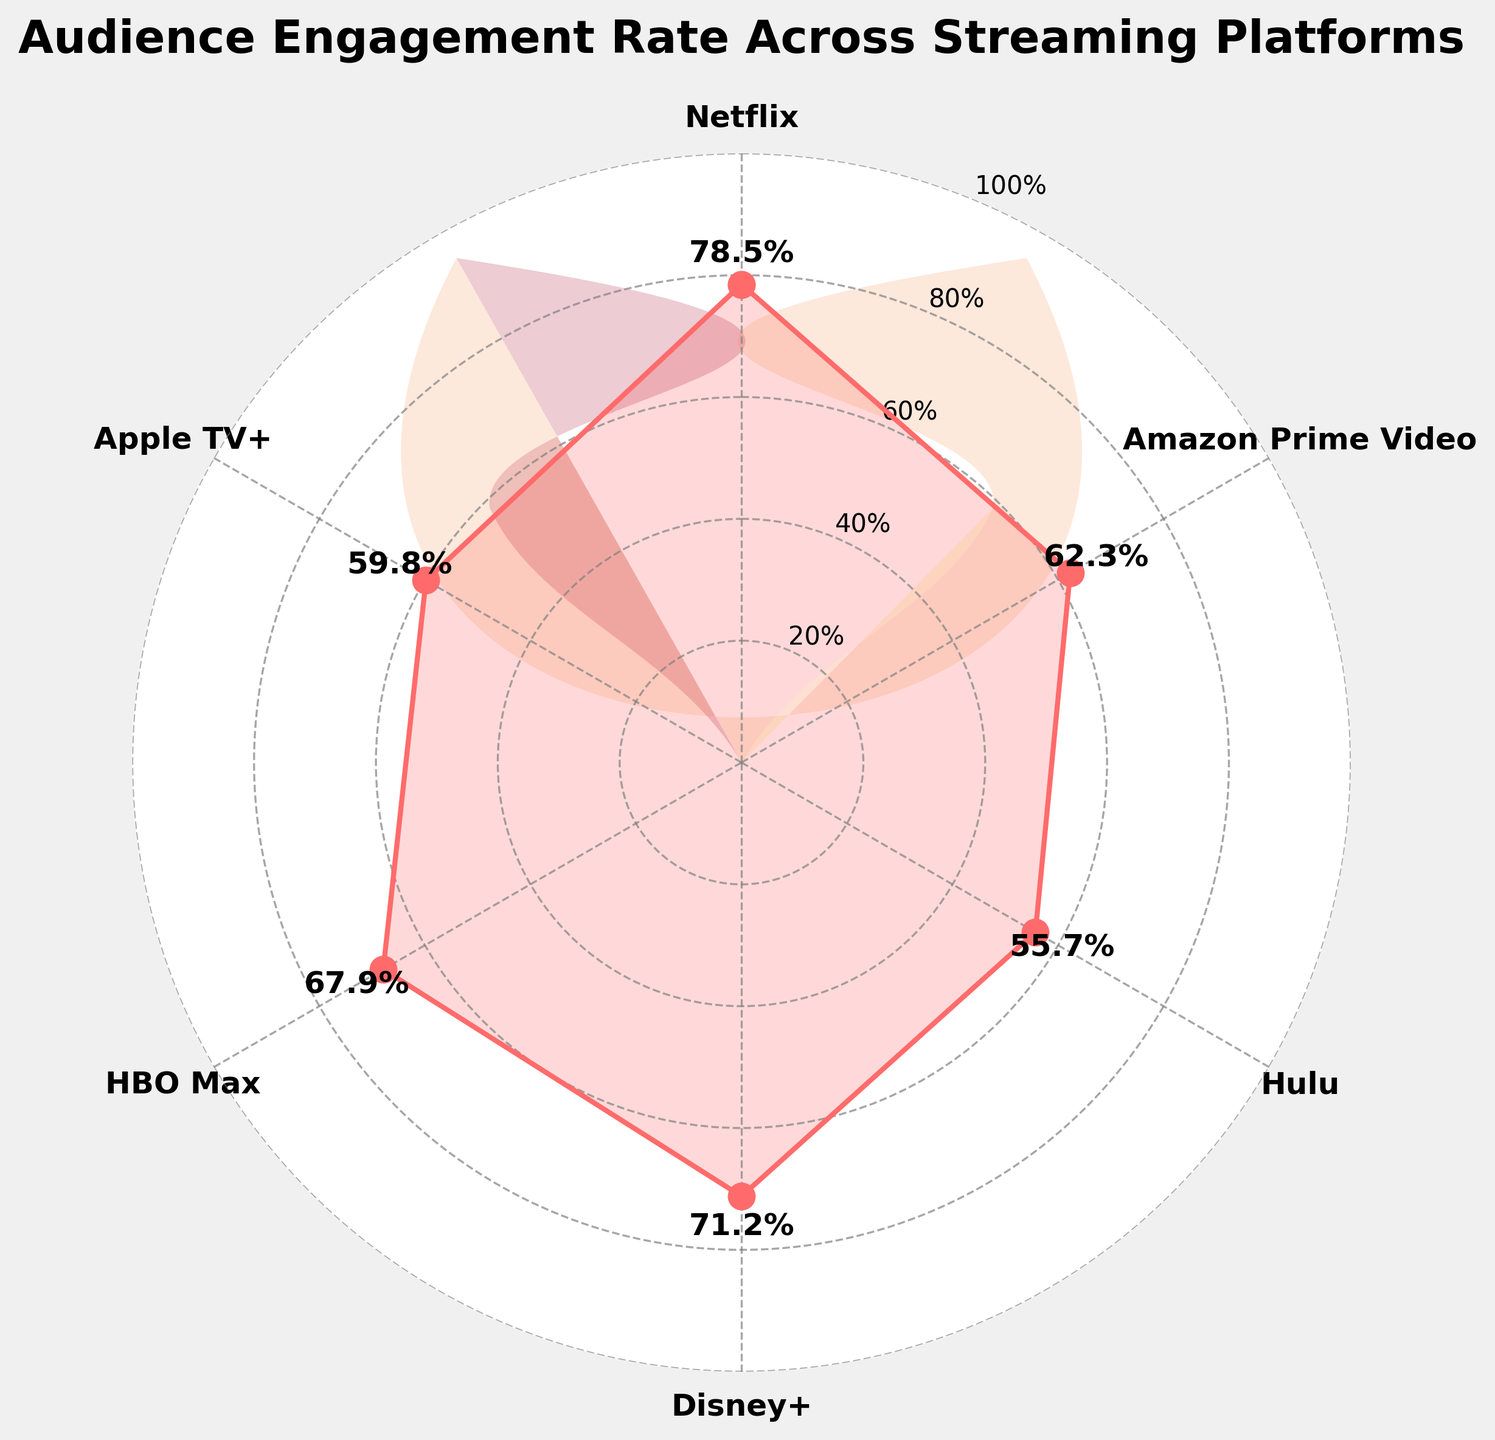What is the title of the figure? The title of the figure is typically displayed at the top of the plot. In this case, it reads "Audience Engagement Rate Across Streaming Platforms".
Answer: "Audience Engagement Rate Across Streaming Platforms" How many streaming platforms are represented in the figure? The figure shows data points for various streaming platforms. Counting the labeled data points around the gauge gives us the number of platforms.
Answer: 6 Which platform has the highest audience engagement rate? Reviewing the engagement rates labeled around the gauge, the highest rate is labeled next to Netflix.
Answer: Netflix Identify the platform with the lowest engagement rate. By comparing the engagement rates around the gauge, the lowest rate is labeled next to Hulu.
Answer: Hulu What is the engagement rate for HBO Max? The engagement rate can be found next to the labeled point for HBO Max. It is written as a percentage.
Answer: 67.9% What is the average engagement rate across all platforms? Adding up all the engagement rates (78.5 + 62.3 + 55.7 + 71.2 + 67.9 + 59.8) and dividing by the number of platforms (6) will give the average engagement rate.
Answer: 65.9% Is Amazon Prime Video's engagement rate higher or lower than Hulu's? Comparing the engagement rates of Amazon Prime Video and Hulu directly from the gauge labels, we see that Amazon Prime Video's rate is higher.
Answer: Higher How much higher is Netflix's engagement rate compared to Apple TV+'s? Subtracting Apple TV+'s engagement rate from Netflix's provides the difference: 78.5 - 59.8.
Answer: 18.7% Which platforms have an engagement rate above 70%? Reviewing the labels on the gauge, the platforms with rates above 70% are Netflix and Disney+.
Answer: Netflix and Disney+ What is the range of engagement rates shown in the figure? The range is found by subtracting the lowest engagement rate (Hulu - 55.7) from the highest (Netflix - 78.5).
Answer: 22.8% 